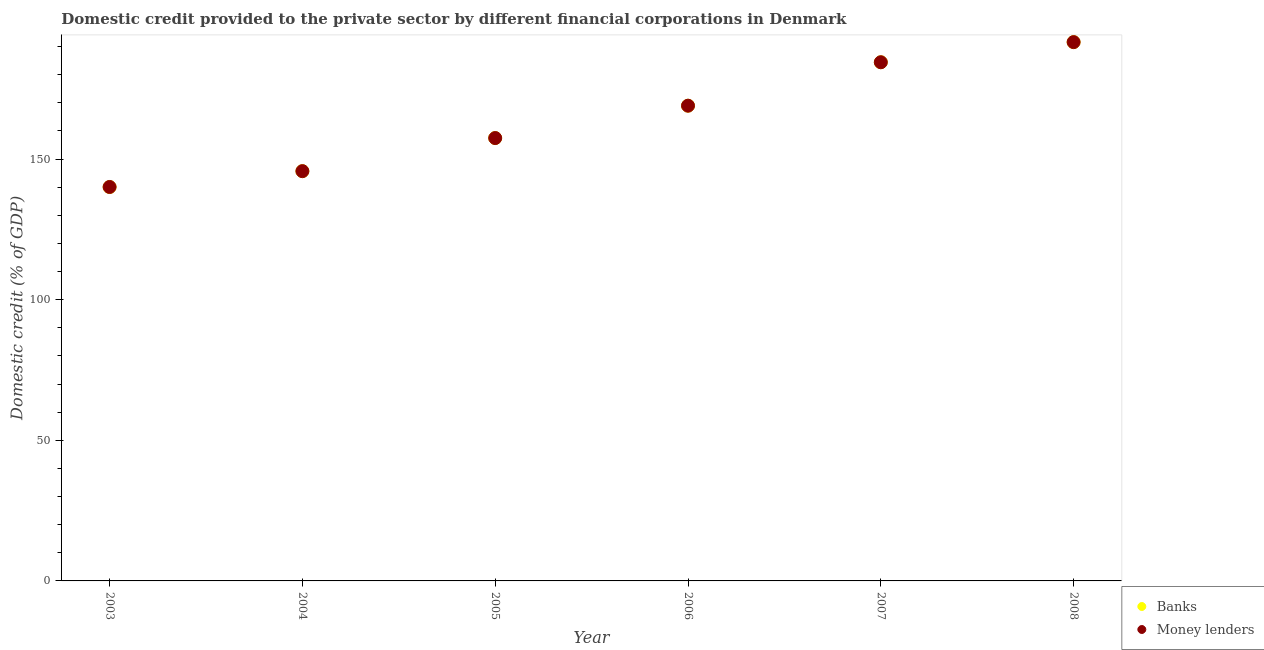Is the number of dotlines equal to the number of legend labels?
Ensure brevity in your answer.  Yes. What is the domestic credit provided by money lenders in 2007?
Provide a short and direct response. 184.45. Across all years, what is the maximum domestic credit provided by money lenders?
Give a very brief answer. 191.61. Across all years, what is the minimum domestic credit provided by banks?
Offer a very short reply. 140.07. In which year was the domestic credit provided by money lenders maximum?
Give a very brief answer. 2008. In which year was the domestic credit provided by banks minimum?
Ensure brevity in your answer.  2003. What is the total domestic credit provided by banks in the graph?
Your response must be concise. 988.34. What is the difference between the domestic credit provided by money lenders in 2004 and that in 2005?
Give a very brief answer. -11.77. What is the difference between the domestic credit provided by money lenders in 2004 and the domestic credit provided by banks in 2005?
Ensure brevity in your answer.  -11.77. What is the average domestic credit provided by banks per year?
Provide a short and direct response. 164.72. In the year 2005, what is the difference between the domestic credit provided by banks and domestic credit provided by money lenders?
Offer a terse response. -0. What is the ratio of the domestic credit provided by banks in 2005 to that in 2008?
Your answer should be compact. 0.82. Is the difference between the domestic credit provided by money lenders in 2006 and 2008 greater than the difference between the domestic credit provided by banks in 2006 and 2008?
Give a very brief answer. Yes. What is the difference between the highest and the second highest domestic credit provided by money lenders?
Your answer should be very brief. 7.16. What is the difference between the highest and the lowest domestic credit provided by money lenders?
Ensure brevity in your answer.  51.51. In how many years, is the domestic credit provided by money lenders greater than the average domestic credit provided by money lenders taken over all years?
Offer a very short reply. 3. Is the sum of the domestic credit provided by money lenders in 2003 and 2004 greater than the maximum domestic credit provided by banks across all years?
Offer a very short reply. Yes. Does the domestic credit provided by banks monotonically increase over the years?
Your answer should be compact. Yes. Is the domestic credit provided by banks strictly less than the domestic credit provided by money lenders over the years?
Offer a very short reply. Yes. How many years are there in the graph?
Make the answer very short. 6. What is the difference between two consecutive major ticks on the Y-axis?
Ensure brevity in your answer.  50. Where does the legend appear in the graph?
Ensure brevity in your answer.  Bottom right. What is the title of the graph?
Your answer should be compact. Domestic credit provided to the private sector by different financial corporations in Denmark. Does "Private credit bureau" appear as one of the legend labels in the graph?
Offer a very short reply. No. What is the label or title of the X-axis?
Give a very brief answer. Year. What is the label or title of the Y-axis?
Provide a succinct answer. Domestic credit (% of GDP). What is the Domestic credit (% of GDP) of Banks in 2003?
Make the answer very short. 140.07. What is the Domestic credit (% of GDP) in Money lenders in 2003?
Offer a terse response. 140.1. What is the Domestic credit (% of GDP) of Banks in 2004?
Give a very brief answer. 145.72. What is the Domestic credit (% of GDP) of Money lenders in 2004?
Give a very brief answer. 145.72. What is the Domestic credit (% of GDP) in Banks in 2005?
Offer a terse response. 157.49. What is the Domestic credit (% of GDP) in Money lenders in 2005?
Keep it short and to the point. 157.49. What is the Domestic credit (% of GDP) in Banks in 2006?
Your response must be concise. 169. What is the Domestic credit (% of GDP) of Money lenders in 2006?
Ensure brevity in your answer.  169. What is the Domestic credit (% of GDP) of Banks in 2007?
Provide a succinct answer. 184.45. What is the Domestic credit (% of GDP) of Money lenders in 2007?
Your answer should be very brief. 184.45. What is the Domestic credit (% of GDP) of Banks in 2008?
Offer a very short reply. 191.61. What is the Domestic credit (% of GDP) in Money lenders in 2008?
Your response must be concise. 191.61. Across all years, what is the maximum Domestic credit (% of GDP) in Banks?
Your response must be concise. 191.61. Across all years, what is the maximum Domestic credit (% of GDP) of Money lenders?
Provide a succinct answer. 191.61. Across all years, what is the minimum Domestic credit (% of GDP) of Banks?
Your answer should be compact. 140.07. Across all years, what is the minimum Domestic credit (% of GDP) in Money lenders?
Keep it short and to the point. 140.1. What is the total Domestic credit (% of GDP) of Banks in the graph?
Give a very brief answer. 988.34. What is the total Domestic credit (% of GDP) of Money lenders in the graph?
Your answer should be very brief. 988.36. What is the difference between the Domestic credit (% of GDP) in Banks in 2003 and that in 2004?
Your answer should be compact. -5.65. What is the difference between the Domestic credit (% of GDP) in Money lenders in 2003 and that in 2004?
Your answer should be compact. -5.63. What is the difference between the Domestic credit (% of GDP) of Banks in 2003 and that in 2005?
Offer a terse response. -17.42. What is the difference between the Domestic credit (% of GDP) in Money lenders in 2003 and that in 2005?
Provide a succinct answer. -17.39. What is the difference between the Domestic credit (% of GDP) of Banks in 2003 and that in 2006?
Provide a succinct answer. -28.93. What is the difference between the Domestic credit (% of GDP) in Money lenders in 2003 and that in 2006?
Offer a very short reply. -28.9. What is the difference between the Domestic credit (% of GDP) in Banks in 2003 and that in 2007?
Provide a succinct answer. -44.37. What is the difference between the Domestic credit (% of GDP) of Money lenders in 2003 and that in 2007?
Offer a terse response. -44.35. What is the difference between the Domestic credit (% of GDP) of Banks in 2003 and that in 2008?
Your response must be concise. -51.53. What is the difference between the Domestic credit (% of GDP) of Money lenders in 2003 and that in 2008?
Give a very brief answer. -51.51. What is the difference between the Domestic credit (% of GDP) of Banks in 2004 and that in 2005?
Provide a short and direct response. -11.77. What is the difference between the Domestic credit (% of GDP) in Money lenders in 2004 and that in 2005?
Your answer should be very brief. -11.77. What is the difference between the Domestic credit (% of GDP) of Banks in 2004 and that in 2006?
Your response must be concise. -23.28. What is the difference between the Domestic credit (% of GDP) in Money lenders in 2004 and that in 2006?
Offer a very short reply. -23.28. What is the difference between the Domestic credit (% of GDP) in Banks in 2004 and that in 2007?
Make the answer very short. -38.73. What is the difference between the Domestic credit (% of GDP) in Money lenders in 2004 and that in 2007?
Your response must be concise. -38.73. What is the difference between the Domestic credit (% of GDP) of Banks in 2004 and that in 2008?
Offer a terse response. -45.88. What is the difference between the Domestic credit (% of GDP) of Money lenders in 2004 and that in 2008?
Ensure brevity in your answer.  -45.88. What is the difference between the Domestic credit (% of GDP) of Banks in 2005 and that in 2006?
Your answer should be compact. -11.51. What is the difference between the Domestic credit (% of GDP) in Money lenders in 2005 and that in 2006?
Your answer should be very brief. -11.51. What is the difference between the Domestic credit (% of GDP) in Banks in 2005 and that in 2007?
Provide a short and direct response. -26.96. What is the difference between the Domestic credit (% of GDP) of Money lenders in 2005 and that in 2007?
Your response must be concise. -26.96. What is the difference between the Domestic credit (% of GDP) in Banks in 2005 and that in 2008?
Your answer should be compact. -34.12. What is the difference between the Domestic credit (% of GDP) in Money lenders in 2005 and that in 2008?
Your response must be concise. -34.12. What is the difference between the Domestic credit (% of GDP) in Banks in 2006 and that in 2007?
Your answer should be very brief. -15.45. What is the difference between the Domestic credit (% of GDP) of Money lenders in 2006 and that in 2007?
Give a very brief answer. -15.45. What is the difference between the Domestic credit (% of GDP) of Banks in 2006 and that in 2008?
Provide a short and direct response. -22.61. What is the difference between the Domestic credit (% of GDP) in Money lenders in 2006 and that in 2008?
Your response must be concise. -22.61. What is the difference between the Domestic credit (% of GDP) of Banks in 2007 and that in 2008?
Keep it short and to the point. -7.16. What is the difference between the Domestic credit (% of GDP) of Money lenders in 2007 and that in 2008?
Offer a terse response. -7.16. What is the difference between the Domestic credit (% of GDP) in Banks in 2003 and the Domestic credit (% of GDP) in Money lenders in 2004?
Provide a succinct answer. -5.65. What is the difference between the Domestic credit (% of GDP) of Banks in 2003 and the Domestic credit (% of GDP) of Money lenders in 2005?
Offer a very short reply. -17.42. What is the difference between the Domestic credit (% of GDP) of Banks in 2003 and the Domestic credit (% of GDP) of Money lenders in 2006?
Make the answer very short. -28.93. What is the difference between the Domestic credit (% of GDP) in Banks in 2003 and the Domestic credit (% of GDP) in Money lenders in 2007?
Your answer should be very brief. -44.37. What is the difference between the Domestic credit (% of GDP) in Banks in 2003 and the Domestic credit (% of GDP) in Money lenders in 2008?
Offer a very short reply. -51.53. What is the difference between the Domestic credit (% of GDP) of Banks in 2004 and the Domestic credit (% of GDP) of Money lenders in 2005?
Ensure brevity in your answer.  -11.77. What is the difference between the Domestic credit (% of GDP) of Banks in 2004 and the Domestic credit (% of GDP) of Money lenders in 2006?
Keep it short and to the point. -23.28. What is the difference between the Domestic credit (% of GDP) of Banks in 2004 and the Domestic credit (% of GDP) of Money lenders in 2007?
Offer a terse response. -38.73. What is the difference between the Domestic credit (% of GDP) of Banks in 2004 and the Domestic credit (% of GDP) of Money lenders in 2008?
Your answer should be compact. -45.88. What is the difference between the Domestic credit (% of GDP) of Banks in 2005 and the Domestic credit (% of GDP) of Money lenders in 2006?
Your answer should be very brief. -11.51. What is the difference between the Domestic credit (% of GDP) of Banks in 2005 and the Domestic credit (% of GDP) of Money lenders in 2007?
Offer a very short reply. -26.96. What is the difference between the Domestic credit (% of GDP) in Banks in 2005 and the Domestic credit (% of GDP) in Money lenders in 2008?
Make the answer very short. -34.12. What is the difference between the Domestic credit (% of GDP) in Banks in 2006 and the Domestic credit (% of GDP) in Money lenders in 2007?
Make the answer very short. -15.45. What is the difference between the Domestic credit (% of GDP) in Banks in 2006 and the Domestic credit (% of GDP) in Money lenders in 2008?
Offer a terse response. -22.61. What is the difference between the Domestic credit (% of GDP) in Banks in 2007 and the Domestic credit (% of GDP) in Money lenders in 2008?
Offer a very short reply. -7.16. What is the average Domestic credit (% of GDP) in Banks per year?
Your response must be concise. 164.72. What is the average Domestic credit (% of GDP) of Money lenders per year?
Give a very brief answer. 164.73. In the year 2003, what is the difference between the Domestic credit (% of GDP) in Banks and Domestic credit (% of GDP) in Money lenders?
Your answer should be compact. -0.02. In the year 2004, what is the difference between the Domestic credit (% of GDP) in Banks and Domestic credit (% of GDP) in Money lenders?
Ensure brevity in your answer.  -0. In the year 2005, what is the difference between the Domestic credit (% of GDP) in Banks and Domestic credit (% of GDP) in Money lenders?
Your answer should be very brief. -0. In the year 2006, what is the difference between the Domestic credit (% of GDP) in Banks and Domestic credit (% of GDP) in Money lenders?
Your answer should be compact. -0. In the year 2007, what is the difference between the Domestic credit (% of GDP) of Banks and Domestic credit (% of GDP) of Money lenders?
Provide a succinct answer. -0. In the year 2008, what is the difference between the Domestic credit (% of GDP) of Banks and Domestic credit (% of GDP) of Money lenders?
Your response must be concise. -0. What is the ratio of the Domestic credit (% of GDP) in Banks in 2003 to that in 2004?
Ensure brevity in your answer.  0.96. What is the ratio of the Domestic credit (% of GDP) of Money lenders in 2003 to that in 2004?
Offer a very short reply. 0.96. What is the ratio of the Domestic credit (% of GDP) in Banks in 2003 to that in 2005?
Make the answer very short. 0.89. What is the ratio of the Domestic credit (% of GDP) of Money lenders in 2003 to that in 2005?
Provide a short and direct response. 0.89. What is the ratio of the Domestic credit (% of GDP) of Banks in 2003 to that in 2006?
Make the answer very short. 0.83. What is the ratio of the Domestic credit (% of GDP) of Money lenders in 2003 to that in 2006?
Ensure brevity in your answer.  0.83. What is the ratio of the Domestic credit (% of GDP) in Banks in 2003 to that in 2007?
Your answer should be very brief. 0.76. What is the ratio of the Domestic credit (% of GDP) in Money lenders in 2003 to that in 2007?
Offer a very short reply. 0.76. What is the ratio of the Domestic credit (% of GDP) in Banks in 2003 to that in 2008?
Your answer should be very brief. 0.73. What is the ratio of the Domestic credit (% of GDP) of Money lenders in 2003 to that in 2008?
Provide a succinct answer. 0.73. What is the ratio of the Domestic credit (% of GDP) of Banks in 2004 to that in 2005?
Your answer should be compact. 0.93. What is the ratio of the Domestic credit (% of GDP) in Money lenders in 2004 to that in 2005?
Provide a short and direct response. 0.93. What is the ratio of the Domestic credit (% of GDP) of Banks in 2004 to that in 2006?
Offer a very short reply. 0.86. What is the ratio of the Domestic credit (% of GDP) in Money lenders in 2004 to that in 2006?
Offer a very short reply. 0.86. What is the ratio of the Domestic credit (% of GDP) in Banks in 2004 to that in 2007?
Your answer should be very brief. 0.79. What is the ratio of the Domestic credit (% of GDP) of Money lenders in 2004 to that in 2007?
Ensure brevity in your answer.  0.79. What is the ratio of the Domestic credit (% of GDP) in Banks in 2004 to that in 2008?
Ensure brevity in your answer.  0.76. What is the ratio of the Domestic credit (% of GDP) of Money lenders in 2004 to that in 2008?
Your answer should be very brief. 0.76. What is the ratio of the Domestic credit (% of GDP) of Banks in 2005 to that in 2006?
Your answer should be very brief. 0.93. What is the ratio of the Domestic credit (% of GDP) of Money lenders in 2005 to that in 2006?
Give a very brief answer. 0.93. What is the ratio of the Domestic credit (% of GDP) of Banks in 2005 to that in 2007?
Provide a succinct answer. 0.85. What is the ratio of the Domestic credit (% of GDP) in Money lenders in 2005 to that in 2007?
Ensure brevity in your answer.  0.85. What is the ratio of the Domestic credit (% of GDP) of Banks in 2005 to that in 2008?
Your answer should be very brief. 0.82. What is the ratio of the Domestic credit (% of GDP) in Money lenders in 2005 to that in 2008?
Your response must be concise. 0.82. What is the ratio of the Domestic credit (% of GDP) in Banks in 2006 to that in 2007?
Your response must be concise. 0.92. What is the ratio of the Domestic credit (% of GDP) in Money lenders in 2006 to that in 2007?
Offer a terse response. 0.92. What is the ratio of the Domestic credit (% of GDP) of Banks in 2006 to that in 2008?
Keep it short and to the point. 0.88. What is the ratio of the Domestic credit (% of GDP) of Money lenders in 2006 to that in 2008?
Keep it short and to the point. 0.88. What is the ratio of the Domestic credit (% of GDP) of Banks in 2007 to that in 2008?
Provide a short and direct response. 0.96. What is the ratio of the Domestic credit (% of GDP) of Money lenders in 2007 to that in 2008?
Make the answer very short. 0.96. What is the difference between the highest and the second highest Domestic credit (% of GDP) of Banks?
Ensure brevity in your answer.  7.16. What is the difference between the highest and the second highest Domestic credit (% of GDP) of Money lenders?
Ensure brevity in your answer.  7.16. What is the difference between the highest and the lowest Domestic credit (% of GDP) of Banks?
Offer a terse response. 51.53. What is the difference between the highest and the lowest Domestic credit (% of GDP) in Money lenders?
Your answer should be very brief. 51.51. 